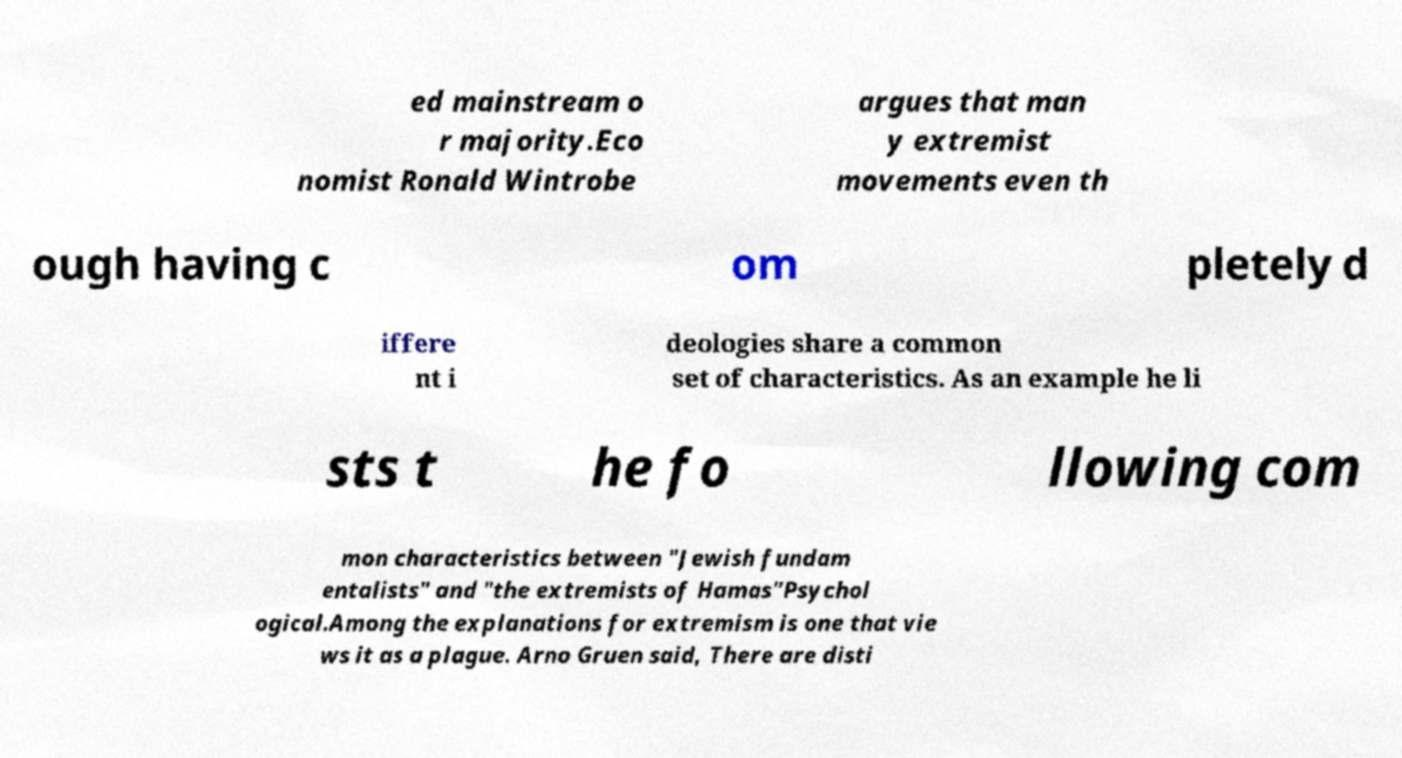Could you extract and type out the text from this image? ed mainstream o r majority.Eco nomist Ronald Wintrobe argues that man y extremist movements even th ough having c om pletely d iffere nt i deologies share a common set of characteristics. As an example he li sts t he fo llowing com mon characteristics between "Jewish fundam entalists" and "the extremists of Hamas"Psychol ogical.Among the explanations for extremism is one that vie ws it as a plague. Arno Gruen said, There are disti 